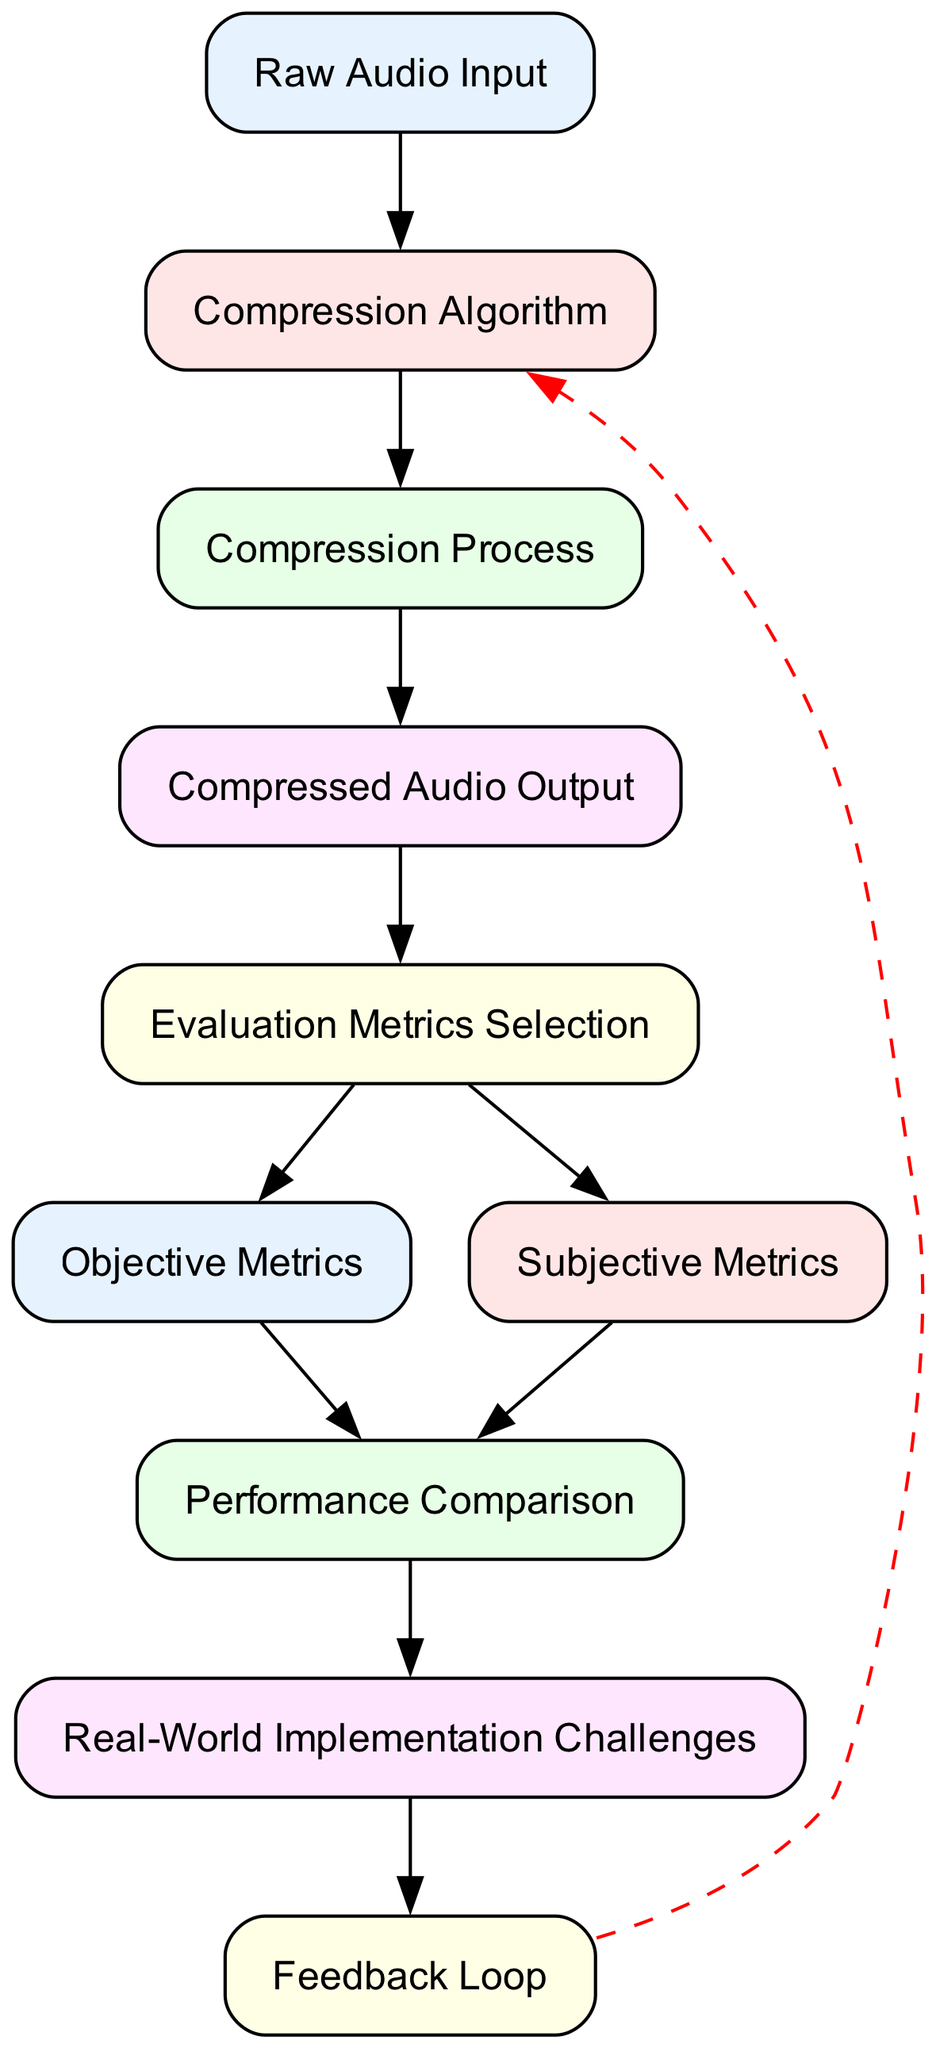What is the initial input to the flow chart? The flow chart starts with "Raw Audio Input," which is the original audio file before any compression takes place.
Answer: Raw Audio Input How many nodes are present in the diagram? By counting each of the distinct elements listed in the flow chart, we find that there are ten different nodes representing various stages of the audio compression process.
Answer: 10 Which node follows the "Compression Algorithm" node? The "Compression Process" node directly follows the "Compression Algorithm" node in the flow chart, indicating the steps taken after selecting the algorithm.
Answer: Compression Process What are the two types of metrics selected after "Metrics Selection"? Following the "Metrics Selection" node, the flow branches into two types of metrics: "Objective Metrics" and "Subjective Metrics," each representing different evaluation approaches.
Answer: Objective Metrics and Subjective Metrics What is the last node in the flow chart before the feedback loop? Before entering the feedback loop, the flow chart lists "Implementation Challenges" as the final step, representing challenges faced in deploying the compression algorithm.
Answer: Implementation Challenges What color represents the "Compressed Audio Output" node? The "Compressed Audio Output" node is filled with color corresponding to the second color in the custom color palette used throughout the flow chart.
Answer: Light Red How does the feedback loop relate to the compression algorithm? The feedback loop allows the evaluation results of the compression performance to be used to refine the "Compression Algorithm," illustrating a cyclical improvement process.
Answer: Refine the Compression Algorithm What is the relationship between "Objective Metrics" and "Performance Comparison"? The flow indicates that "Objective Metrics" feeds into "Performance Comparison," highlighting that objective measures are part of assessing the performance against other algorithms.
Answer: Performance Comparison Which node leads to the evaluation of subjective experiences? The node "Subjective Metrics" leads to evaluating subjective experiences, indicating that qualitative assessments follow after selecting evaluation metrics.
Answer: Subjective Metrics 